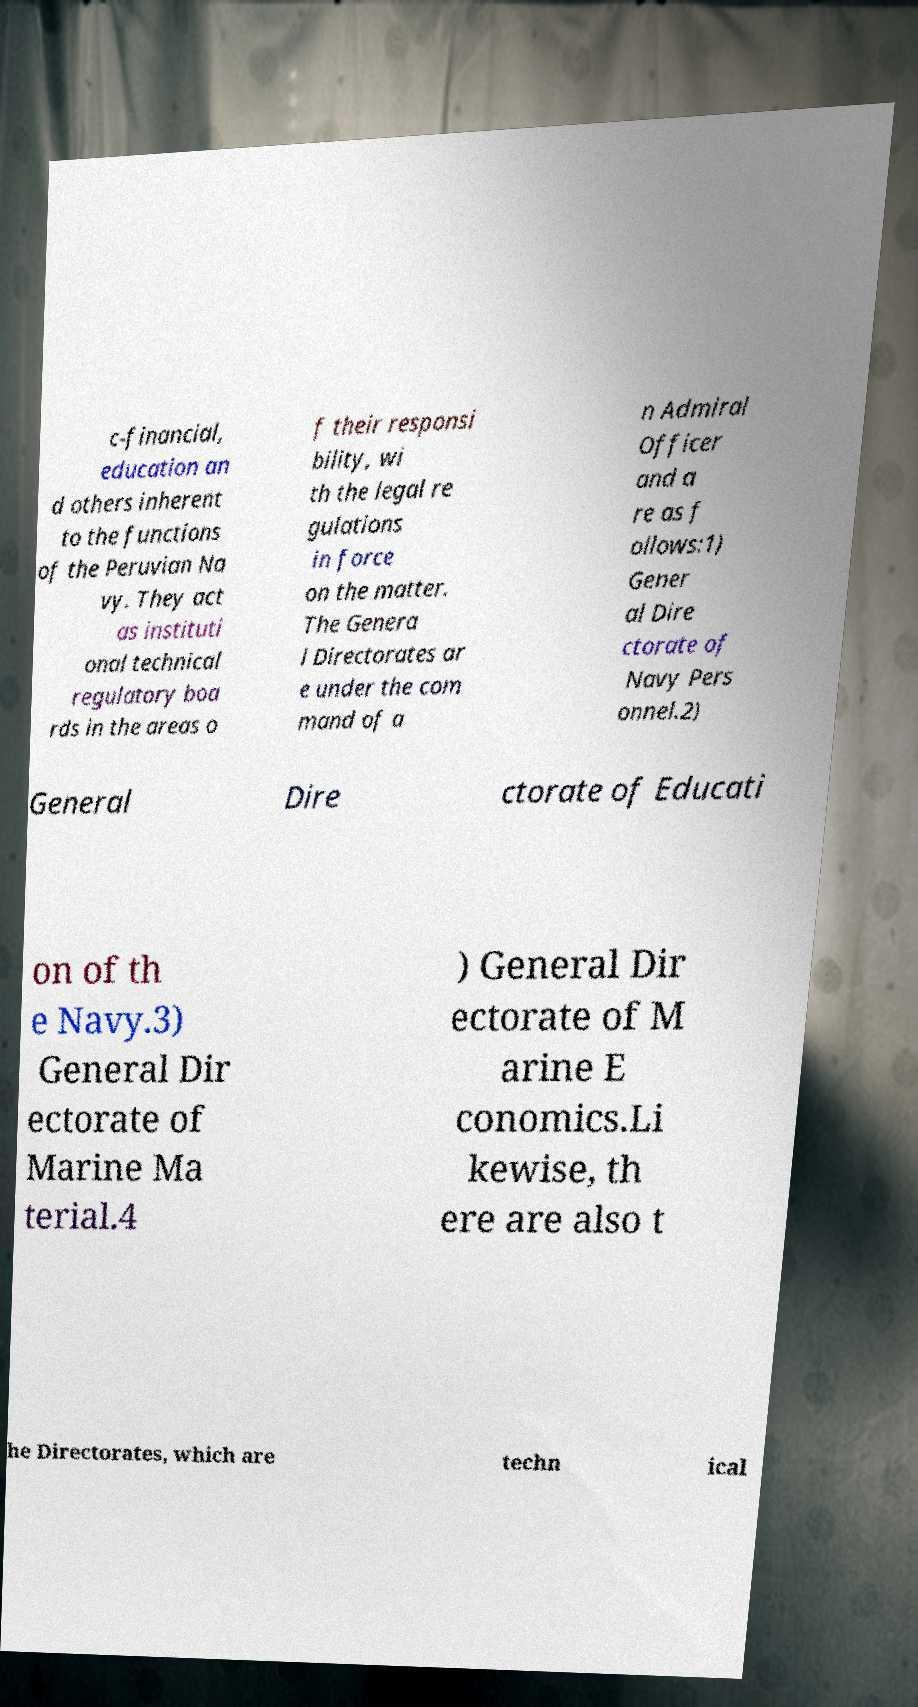What messages or text are displayed in this image? I need them in a readable, typed format. c-financial, education an d others inherent to the functions of the Peruvian Na vy. They act as instituti onal technical regulatory boa rds in the areas o f their responsi bility, wi th the legal re gulations in force on the matter. The Genera l Directorates ar e under the com mand of a n Admiral Officer and a re as f ollows:1) Gener al Dire ctorate of Navy Pers onnel.2) General Dire ctorate of Educati on of th e Navy.3) General Dir ectorate of Marine Ma terial.4 ) General Dir ectorate of M arine E conomics.Li kewise, th ere are also t he Directorates, which are techn ical 